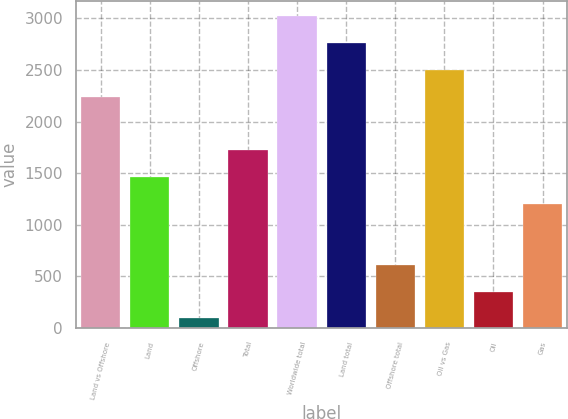<chart> <loc_0><loc_0><loc_500><loc_500><bar_chart><fcel>Land vs Offshore<fcel>Land<fcel>Offshore<fcel>Total<fcel>Worldwide total<fcel>Land total<fcel>Offshore total<fcel>Oil vs Gas<fcel>Oil<fcel>Gas<nl><fcel>2243<fcel>1464.2<fcel>93<fcel>1723.8<fcel>3021.8<fcel>2762.2<fcel>612.2<fcel>2502.6<fcel>352.6<fcel>1204.6<nl></chart> 